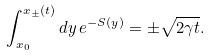Convert formula to latex. <formula><loc_0><loc_0><loc_500><loc_500>\int ^ { x _ { \pm } ( t ) } _ { x _ { 0 } } d y \, e ^ { - S ( y ) } = \pm \sqrt { 2 \gamma t } .</formula> 